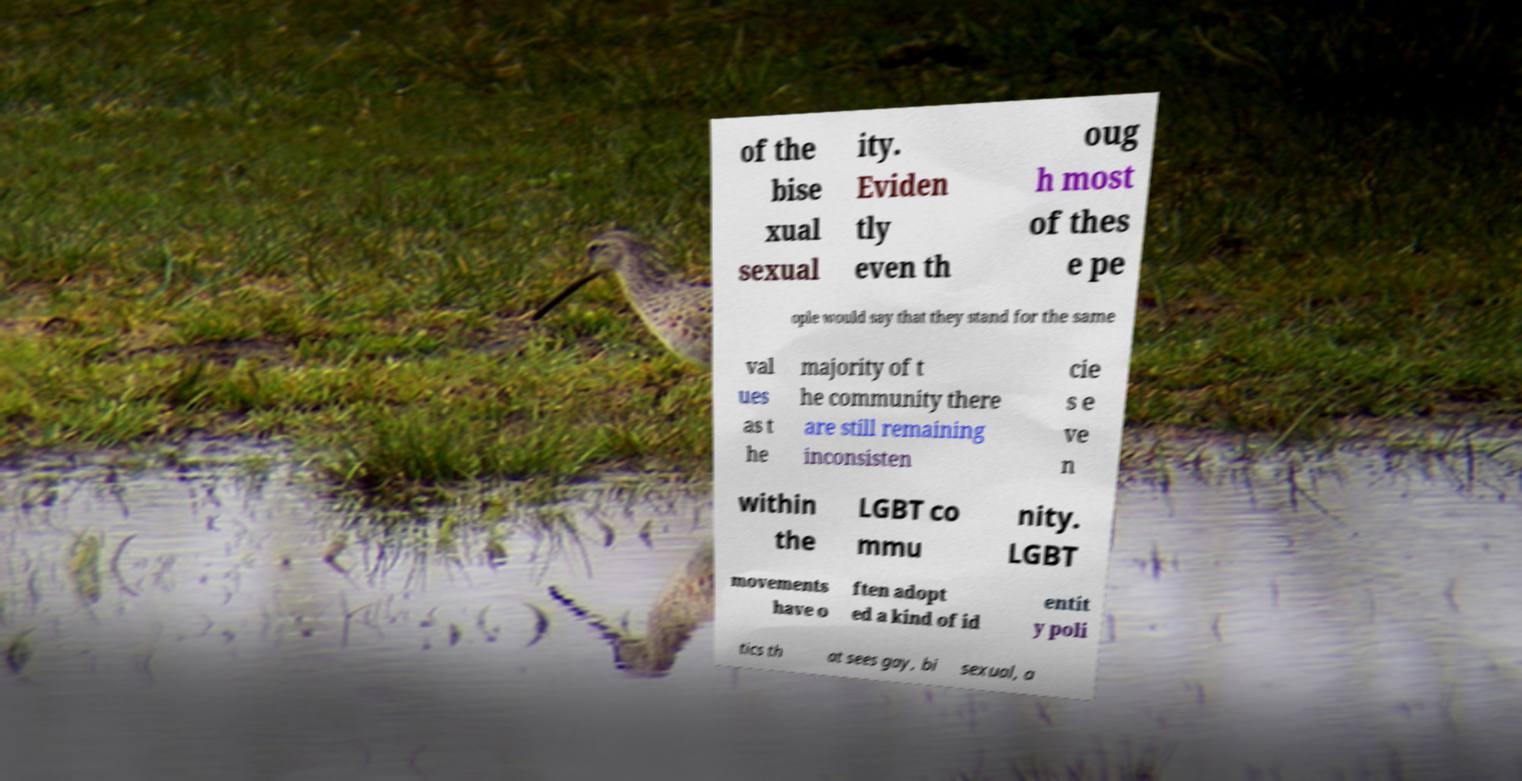I need the written content from this picture converted into text. Can you do that? of the bise xual sexual ity. Eviden tly even th oug h most of thes e pe ople would say that they stand for the same val ues as t he majority of t he community there are still remaining inconsisten cie s e ve n within the LGBT co mmu nity. LGBT movements have o ften adopt ed a kind of id entit y poli tics th at sees gay, bi sexual, a 